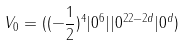Convert formula to latex. <formula><loc_0><loc_0><loc_500><loc_500>V _ { 0 } = ( ( - \frac { 1 } { 2 } ) ^ { 4 } | 0 ^ { 6 } | | 0 ^ { 2 2 - 2 d } | 0 ^ { d } )</formula> 